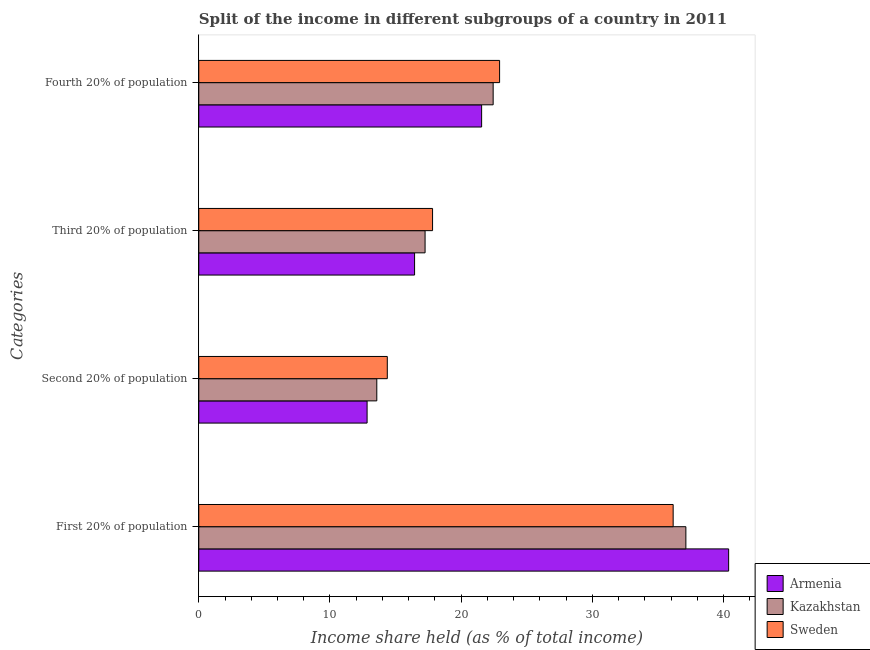How many different coloured bars are there?
Offer a very short reply. 3. How many groups of bars are there?
Provide a short and direct response. 4. Are the number of bars on each tick of the Y-axis equal?
Provide a succinct answer. Yes. How many bars are there on the 4th tick from the top?
Ensure brevity in your answer.  3. What is the label of the 4th group of bars from the top?
Give a very brief answer. First 20% of population. What is the share of the income held by first 20% of the population in Kazakhstan?
Provide a succinct answer. 37.13. Across all countries, what is the maximum share of the income held by third 20% of the population?
Ensure brevity in your answer.  17.82. Across all countries, what is the minimum share of the income held by first 20% of the population?
Your answer should be very brief. 36.16. In which country was the share of the income held by second 20% of the population maximum?
Your response must be concise. Sweden. In which country was the share of the income held by first 20% of the population minimum?
Your answer should be compact. Sweden. What is the total share of the income held by third 20% of the population in the graph?
Give a very brief answer. 51.52. What is the difference between the share of the income held by first 20% of the population in Sweden and that in Armenia?
Your response must be concise. -4.23. What is the difference between the share of the income held by second 20% of the population in Kazakhstan and the share of the income held by first 20% of the population in Sweden?
Offer a very short reply. -22.59. What is the average share of the income held by fourth 20% of the population per country?
Keep it short and to the point. 22.31. What is the difference between the share of the income held by fourth 20% of the population and share of the income held by second 20% of the population in Sweden?
Make the answer very short. 8.56. In how many countries, is the share of the income held by third 20% of the population greater than 8 %?
Offer a very short reply. 3. What is the ratio of the share of the income held by third 20% of the population in Armenia to that in Kazakhstan?
Your response must be concise. 0.95. Is the share of the income held by third 20% of the population in Sweden less than that in Armenia?
Give a very brief answer. No. What is the difference between the highest and the second highest share of the income held by third 20% of the population?
Your response must be concise. 0.57. What is the difference between the highest and the lowest share of the income held by second 20% of the population?
Provide a short and direct response. 1.54. In how many countries, is the share of the income held by second 20% of the population greater than the average share of the income held by second 20% of the population taken over all countries?
Offer a very short reply. 1. Is the sum of the share of the income held by first 20% of the population in Sweden and Armenia greater than the maximum share of the income held by second 20% of the population across all countries?
Offer a very short reply. Yes. Is it the case that in every country, the sum of the share of the income held by third 20% of the population and share of the income held by second 20% of the population is greater than the sum of share of the income held by first 20% of the population and share of the income held by fourth 20% of the population?
Provide a succinct answer. No. What does the 2nd bar from the top in Third 20% of population represents?
Give a very brief answer. Kazakhstan. What does the 3rd bar from the bottom in Second 20% of population represents?
Your answer should be compact. Sweden. Is it the case that in every country, the sum of the share of the income held by first 20% of the population and share of the income held by second 20% of the population is greater than the share of the income held by third 20% of the population?
Your response must be concise. Yes. Are all the bars in the graph horizontal?
Provide a short and direct response. Yes. What is the difference between two consecutive major ticks on the X-axis?
Your response must be concise. 10. Are the values on the major ticks of X-axis written in scientific E-notation?
Keep it short and to the point. No. Does the graph contain grids?
Provide a succinct answer. No. How are the legend labels stacked?
Provide a short and direct response. Vertical. What is the title of the graph?
Provide a succinct answer. Split of the income in different subgroups of a country in 2011. Does "South Asia" appear as one of the legend labels in the graph?
Make the answer very short. No. What is the label or title of the X-axis?
Keep it short and to the point. Income share held (as % of total income). What is the label or title of the Y-axis?
Ensure brevity in your answer.  Categories. What is the Income share held (as % of total income) in Armenia in First 20% of population?
Give a very brief answer. 40.39. What is the Income share held (as % of total income) of Kazakhstan in First 20% of population?
Offer a very short reply. 37.13. What is the Income share held (as % of total income) in Sweden in First 20% of population?
Offer a terse response. 36.16. What is the Income share held (as % of total income) in Armenia in Second 20% of population?
Ensure brevity in your answer.  12.83. What is the Income share held (as % of total income) of Kazakhstan in Second 20% of population?
Ensure brevity in your answer.  13.57. What is the Income share held (as % of total income) in Sweden in Second 20% of population?
Provide a short and direct response. 14.37. What is the Income share held (as % of total income) in Armenia in Third 20% of population?
Ensure brevity in your answer.  16.45. What is the Income share held (as % of total income) in Kazakhstan in Third 20% of population?
Give a very brief answer. 17.25. What is the Income share held (as % of total income) of Sweden in Third 20% of population?
Offer a terse response. 17.82. What is the Income share held (as % of total income) in Armenia in Fourth 20% of population?
Provide a short and direct response. 21.56. What is the Income share held (as % of total income) of Kazakhstan in Fourth 20% of population?
Offer a very short reply. 22.44. What is the Income share held (as % of total income) in Sweden in Fourth 20% of population?
Offer a very short reply. 22.93. Across all Categories, what is the maximum Income share held (as % of total income) in Armenia?
Make the answer very short. 40.39. Across all Categories, what is the maximum Income share held (as % of total income) of Kazakhstan?
Offer a very short reply. 37.13. Across all Categories, what is the maximum Income share held (as % of total income) in Sweden?
Offer a very short reply. 36.16. Across all Categories, what is the minimum Income share held (as % of total income) in Armenia?
Offer a very short reply. 12.83. Across all Categories, what is the minimum Income share held (as % of total income) of Kazakhstan?
Provide a succinct answer. 13.57. Across all Categories, what is the minimum Income share held (as % of total income) in Sweden?
Offer a terse response. 14.37. What is the total Income share held (as % of total income) of Armenia in the graph?
Provide a short and direct response. 91.23. What is the total Income share held (as % of total income) in Kazakhstan in the graph?
Provide a short and direct response. 90.39. What is the total Income share held (as % of total income) in Sweden in the graph?
Provide a short and direct response. 91.28. What is the difference between the Income share held (as % of total income) of Armenia in First 20% of population and that in Second 20% of population?
Ensure brevity in your answer.  27.56. What is the difference between the Income share held (as % of total income) in Kazakhstan in First 20% of population and that in Second 20% of population?
Offer a very short reply. 23.56. What is the difference between the Income share held (as % of total income) of Sweden in First 20% of population and that in Second 20% of population?
Give a very brief answer. 21.79. What is the difference between the Income share held (as % of total income) in Armenia in First 20% of population and that in Third 20% of population?
Offer a very short reply. 23.94. What is the difference between the Income share held (as % of total income) in Kazakhstan in First 20% of population and that in Third 20% of population?
Make the answer very short. 19.88. What is the difference between the Income share held (as % of total income) in Sweden in First 20% of population and that in Third 20% of population?
Offer a very short reply. 18.34. What is the difference between the Income share held (as % of total income) of Armenia in First 20% of population and that in Fourth 20% of population?
Ensure brevity in your answer.  18.83. What is the difference between the Income share held (as % of total income) of Kazakhstan in First 20% of population and that in Fourth 20% of population?
Your answer should be very brief. 14.69. What is the difference between the Income share held (as % of total income) of Sweden in First 20% of population and that in Fourth 20% of population?
Keep it short and to the point. 13.23. What is the difference between the Income share held (as % of total income) of Armenia in Second 20% of population and that in Third 20% of population?
Offer a very short reply. -3.62. What is the difference between the Income share held (as % of total income) in Kazakhstan in Second 20% of population and that in Third 20% of population?
Ensure brevity in your answer.  -3.68. What is the difference between the Income share held (as % of total income) in Sweden in Second 20% of population and that in Third 20% of population?
Offer a very short reply. -3.45. What is the difference between the Income share held (as % of total income) of Armenia in Second 20% of population and that in Fourth 20% of population?
Your answer should be very brief. -8.73. What is the difference between the Income share held (as % of total income) in Kazakhstan in Second 20% of population and that in Fourth 20% of population?
Make the answer very short. -8.87. What is the difference between the Income share held (as % of total income) of Sweden in Second 20% of population and that in Fourth 20% of population?
Your answer should be very brief. -8.56. What is the difference between the Income share held (as % of total income) of Armenia in Third 20% of population and that in Fourth 20% of population?
Offer a terse response. -5.11. What is the difference between the Income share held (as % of total income) of Kazakhstan in Third 20% of population and that in Fourth 20% of population?
Offer a terse response. -5.19. What is the difference between the Income share held (as % of total income) of Sweden in Third 20% of population and that in Fourth 20% of population?
Make the answer very short. -5.11. What is the difference between the Income share held (as % of total income) of Armenia in First 20% of population and the Income share held (as % of total income) of Kazakhstan in Second 20% of population?
Keep it short and to the point. 26.82. What is the difference between the Income share held (as % of total income) in Armenia in First 20% of population and the Income share held (as % of total income) in Sweden in Second 20% of population?
Provide a succinct answer. 26.02. What is the difference between the Income share held (as % of total income) in Kazakhstan in First 20% of population and the Income share held (as % of total income) in Sweden in Second 20% of population?
Offer a terse response. 22.76. What is the difference between the Income share held (as % of total income) of Armenia in First 20% of population and the Income share held (as % of total income) of Kazakhstan in Third 20% of population?
Provide a short and direct response. 23.14. What is the difference between the Income share held (as % of total income) of Armenia in First 20% of population and the Income share held (as % of total income) of Sweden in Third 20% of population?
Your response must be concise. 22.57. What is the difference between the Income share held (as % of total income) in Kazakhstan in First 20% of population and the Income share held (as % of total income) in Sweden in Third 20% of population?
Ensure brevity in your answer.  19.31. What is the difference between the Income share held (as % of total income) of Armenia in First 20% of population and the Income share held (as % of total income) of Kazakhstan in Fourth 20% of population?
Provide a short and direct response. 17.95. What is the difference between the Income share held (as % of total income) of Armenia in First 20% of population and the Income share held (as % of total income) of Sweden in Fourth 20% of population?
Give a very brief answer. 17.46. What is the difference between the Income share held (as % of total income) in Kazakhstan in First 20% of population and the Income share held (as % of total income) in Sweden in Fourth 20% of population?
Your response must be concise. 14.2. What is the difference between the Income share held (as % of total income) in Armenia in Second 20% of population and the Income share held (as % of total income) in Kazakhstan in Third 20% of population?
Offer a very short reply. -4.42. What is the difference between the Income share held (as % of total income) in Armenia in Second 20% of population and the Income share held (as % of total income) in Sweden in Third 20% of population?
Offer a terse response. -4.99. What is the difference between the Income share held (as % of total income) of Kazakhstan in Second 20% of population and the Income share held (as % of total income) of Sweden in Third 20% of population?
Your response must be concise. -4.25. What is the difference between the Income share held (as % of total income) in Armenia in Second 20% of population and the Income share held (as % of total income) in Kazakhstan in Fourth 20% of population?
Your answer should be very brief. -9.61. What is the difference between the Income share held (as % of total income) in Armenia in Second 20% of population and the Income share held (as % of total income) in Sweden in Fourth 20% of population?
Offer a terse response. -10.1. What is the difference between the Income share held (as % of total income) of Kazakhstan in Second 20% of population and the Income share held (as % of total income) of Sweden in Fourth 20% of population?
Give a very brief answer. -9.36. What is the difference between the Income share held (as % of total income) in Armenia in Third 20% of population and the Income share held (as % of total income) in Kazakhstan in Fourth 20% of population?
Keep it short and to the point. -5.99. What is the difference between the Income share held (as % of total income) in Armenia in Third 20% of population and the Income share held (as % of total income) in Sweden in Fourth 20% of population?
Offer a terse response. -6.48. What is the difference between the Income share held (as % of total income) in Kazakhstan in Third 20% of population and the Income share held (as % of total income) in Sweden in Fourth 20% of population?
Keep it short and to the point. -5.68. What is the average Income share held (as % of total income) in Armenia per Categories?
Your response must be concise. 22.81. What is the average Income share held (as % of total income) of Kazakhstan per Categories?
Offer a very short reply. 22.6. What is the average Income share held (as % of total income) of Sweden per Categories?
Offer a terse response. 22.82. What is the difference between the Income share held (as % of total income) in Armenia and Income share held (as % of total income) in Kazakhstan in First 20% of population?
Your answer should be very brief. 3.26. What is the difference between the Income share held (as % of total income) of Armenia and Income share held (as % of total income) of Sweden in First 20% of population?
Offer a terse response. 4.23. What is the difference between the Income share held (as % of total income) of Armenia and Income share held (as % of total income) of Kazakhstan in Second 20% of population?
Your response must be concise. -0.74. What is the difference between the Income share held (as % of total income) of Armenia and Income share held (as % of total income) of Sweden in Second 20% of population?
Your answer should be very brief. -1.54. What is the difference between the Income share held (as % of total income) in Armenia and Income share held (as % of total income) in Sweden in Third 20% of population?
Make the answer very short. -1.37. What is the difference between the Income share held (as % of total income) of Kazakhstan and Income share held (as % of total income) of Sweden in Third 20% of population?
Make the answer very short. -0.57. What is the difference between the Income share held (as % of total income) in Armenia and Income share held (as % of total income) in Kazakhstan in Fourth 20% of population?
Provide a short and direct response. -0.88. What is the difference between the Income share held (as % of total income) in Armenia and Income share held (as % of total income) in Sweden in Fourth 20% of population?
Keep it short and to the point. -1.37. What is the difference between the Income share held (as % of total income) of Kazakhstan and Income share held (as % of total income) of Sweden in Fourth 20% of population?
Offer a terse response. -0.49. What is the ratio of the Income share held (as % of total income) of Armenia in First 20% of population to that in Second 20% of population?
Your answer should be compact. 3.15. What is the ratio of the Income share held (as % of total income) of Kazakhstan in First 20% of population to that in Second 20% of population?
Make the answer very short. 2.74. What is the ratio of the Income share held (as % of total income) of Sweden in First 20% of population to that in Second 20% of population?
Ensure brevity in your answer.  2.52. What is the ratio of the Income share held (as % of total income) of Armenia in First 20% of population to that in Third 20% of population?
Ensure brevity in your answer.  2.46. What is the ratio of the Income share held (as % of total income) of Kazakhstan in First 20% of population to that in Third 20% of population?
Provide a short and direct response. 2.15. What is the ratio of the Income share held (as % of total income) of Sweden in First 20% of population to that in Third 20% of population?
Your answer should be compact. 2.03. What is the ratio of the Income share held (as % of total income) of Armenia in First 20% of population to that in Fourth 20% of population?
Offer a terse response. 1.87. What is the ratio of the Income share held (as % of total income) in Kazakhstan in First 20% of population to that in Fourth 20% of population?
Your answer should be compact. 1.65. What is the ratio of the Income share held (as % of total income) in Sweden in First 20% of population to that in Fourth 20% of population?
Provide a short and direct response. 1.58. What is the ratio of the Income share held (as % of total income) of Armenia in Second 20% of population to that in Third 20% of population?
Your answer should be very brief. 0.78. What is the ratio of the Income share held (as % of total income) in Kazakhstan in Second 20% of population to that in Third 20% of population?
Provide a short and direct response. 0.79. What is the ratio of the Income share held (as % of total income) in Sweden in Second 20% of population to that in Third 20% of population?
Make the answer very short. 0.81. What is the ratio of the Income share held (as % of total income) of Armenia in Second 20% of population to that in Fourth 20% of population?
Your answer should be compact. 0.6. What is the ratio of the Income share held (as % of total income) of Kazakhstan in Second 20% of population to that in Fourth 20% of population?
Provide a succinct answer. 0.6. What is the ratio of the Income share held (as % of total income) in Sweden in Second 20% of population to that in Fourth 20% of population?
Make the answer very short. 0.63. What is the ratio of the Income share held (as % of total income) of Armenia in Third 20% of population to that in Fourth 20% of population?
Provide a succinct answer. 0.76. What is the ratio of the Income share held (as % of total income) in Kazakhstan in Third 20% of population to that in Fourth 20% of population?
Provide a short and direct response. 0.77. What is the ratio of the Income share held (as % of total income) of Sweden in Third 20% of population to that in Fourth 20% of population?
Your response must be concise. 0.78. What is the difference between the highest and the second highest Income share held (as % of total income) of Armenia?
Offer a terse response. 18.83. What is the difference between the highest and the second highest Income share held (as % of total income) in Kazakhstan?
Your answer should be compact. 14.69. What is the difference between the highest and the second highest Income share held (as % of total income) of Sweden?
Give a very brief answer. 13.23. What is the difference between the highest and the lowest Income share held (as % of total income) of Armenia?
Offer a terse response. 27.56. What is the difference between the highest and the lowest Income share held (as % of total income) in Kazakhstan?
Offer a terse response. 23.56. What is the difference between the highest and the lowest Income share held (as % of total income) of Sweden?
Ensure brevity in your answer.  21.79. 